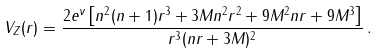<formula> <loc_0><loc_0><loc_500><loc_500>V _ { Z } ( r ) = \frac { 2 e ^ { \nu } \left [ n ^ { 2 } ( n + 1 ) r ^ { 3 } + 3 M n ^ { 2 } r ^ { 2 } + 9 M ^ { 2 } n r + 9 M ^ { 3 } \right ] } { r ^ { 3 } ( n r + 3 M ) ^ { 2 } } \, .</formula> 